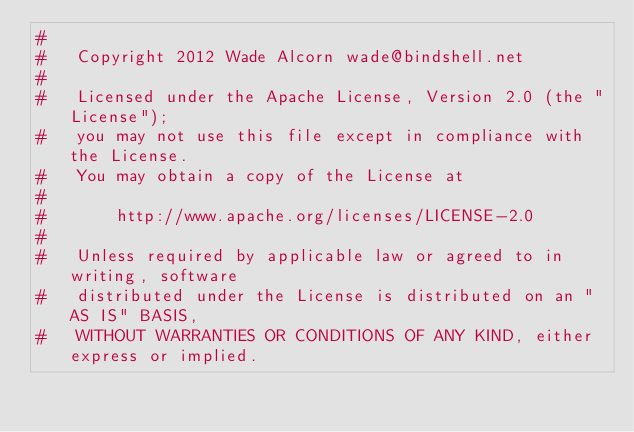Convert code to text. <code><loc_0><loc_0><loc_500><loc_500><_Ruby_>#
#   Copyright 2012 Wade Alcorn wade@bindshell.net
#
#   Licensed under the Apache License, Version 2.0 (the "License");
#   you may not use this file except in compliance with the License.
#   You may obtain a copy of the License at
#
#       http://www.apache.org/licenses/LICENSE-2.0
#
#   Unless required by applicable law or agreed to in writing, software
#   distributed under the License is distributed on an "AS IS" BASIS,
#   WITHOUT WARRANTIES OR CONDITIONS OF ANY KIND, either express or implied.</code> 